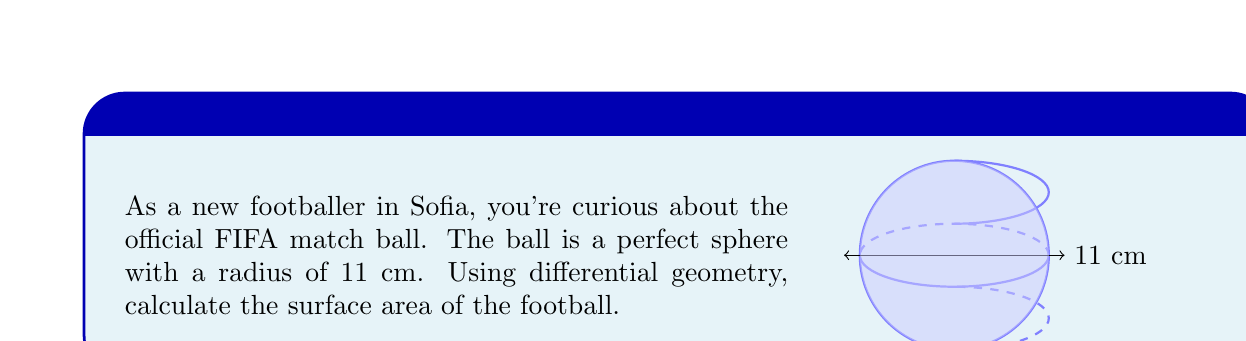Give your solution to this math problem. To find the surface area of a sphere using differential geometry, we can follow these steps:

1) In differential geometry, the surface area of a sphere is given by the double integral:

   $$A = \int_0^{2\pi} \int_0^\pi r^2 \sin\theta \, d\theta \, d\phi$$

   where $r$ is the radius, $\theta$ is the polar angle, and $\phi$ is the azimuthal angle.

2) In this case, $r = 11$ cm. Let's substitute this:

   $$A = 11^2 \int_0^{2\pi} \int_0^\pi \sin\theta \, d\theta \, d\phi$$

3) First, let's solve the inner integral:

   $$\int_0^\pi \sin\theta \, d\theta = [-\cos\theta]_0^\pi = -\cos\pi - (-\cos0) = 1 - (-1) = 2$$

4) Now our integral becomes:

   $$A = 11^2 \cdot 2 \int_0^{2\pi} d\phi$$

5) Solving this:

   $$A = 11^2 \cdot 2 \cdot [2\pi] = 4\pi \cdot 11^2 = 4\pi \cdot 121$$

6) Calculate the final result:

   $$A = 1519.76... \text{ cm}^2$$

Therefore, the surface area of the football is approximately 1519.76 square centimeters.
Answer: $4\pi r^2 \approx 1519.76 \text{ cm}^2$ 